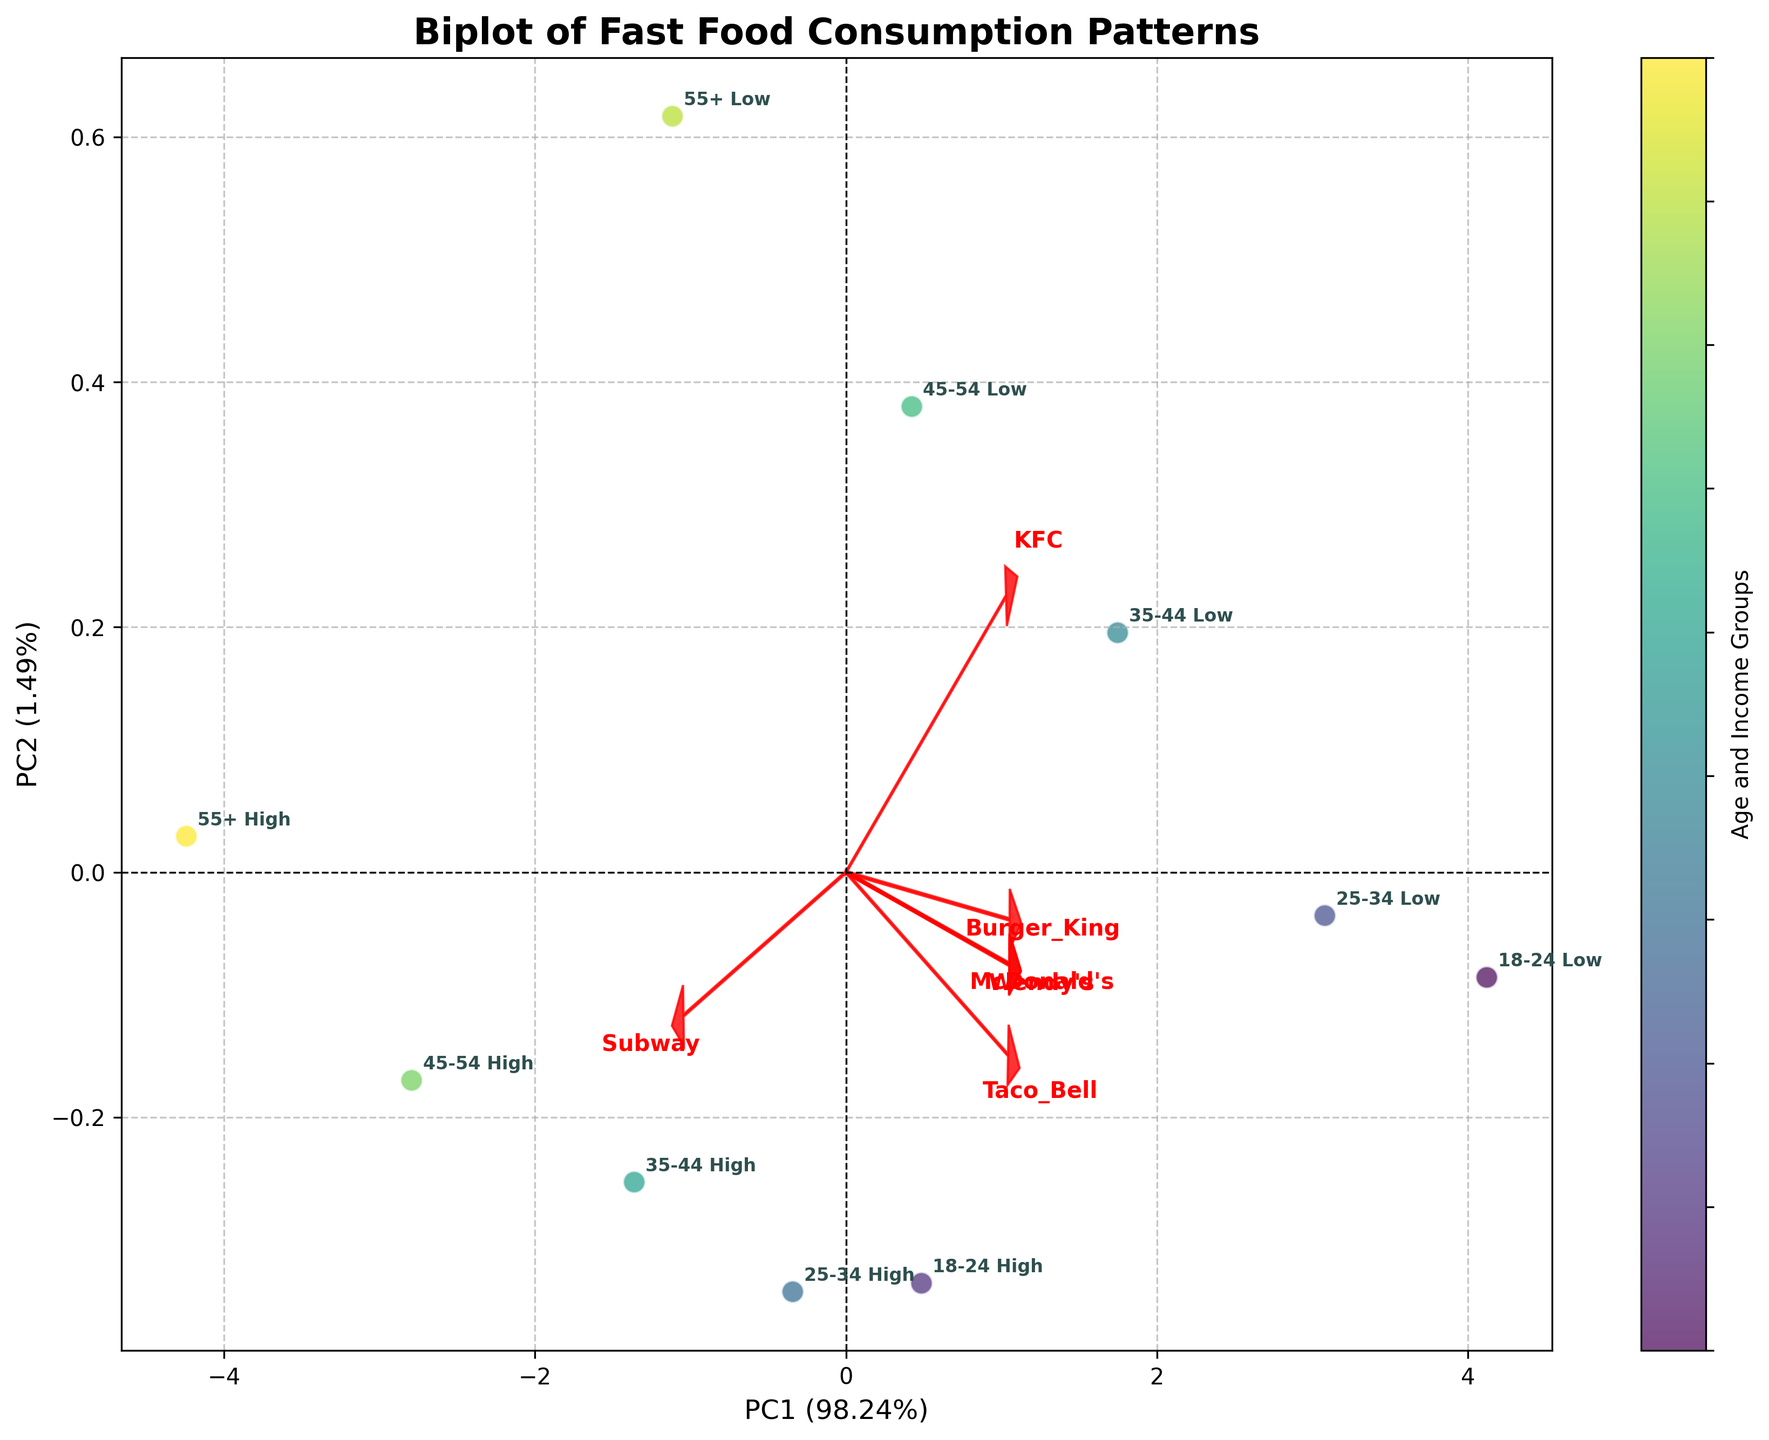What is the title of the plot? The title is typically located at the top of the plot, and it describes the content of the figure.
Answer: Biplot of Fast Food Consumption Patterns Which axis explains the larger percentage of variance? The percentage of variance explained by each axis is labeled on the x and y axes. Here, the x-axis (PC1) has a percentage followed by the y-axis (PC2).
Answer: PC1 What are the labels of the x and y axes? The x and y axes labels are found along the respective axes and indicate what the principal components represent.
Answer: PC1 and PC2 How many distinct groups are labeled on the plot? The annotated text next to each data point represents the combination of age group and income level, which form distinct groups. Count the unique combinations.
Answer: 10 Which fast food chain has a high positive loading on PC1 and PC2? The direction and length of the arrows representing loadings indicate the contribution of each fast food chain. The one with a high positive value on both PC1 and PC2 will be identified by the direction of the red arrows.
Answer: Subway For the age group "18-24 Low", which principal component score is higher, PC1 or PC2? Look at the position of the "18-24 Low" data point along the PC1 (x-axis) and PC2 (y-axis) to determine which has a higher value.
Answer: PC1 Compare the consumption of McDonald's between "18-24 Low" and "55+ High" income groups. Which group consumes more? The plot positions these groups according to their principal component scores, which are influenced by their consumption patterns. Identify their relative positions with respect to the McDonald’s loading vector.
Answer: 18-24 Low Which age and income group is closest to the Taco Bell loading vector? Identify the direction of the Taco Bell loading vector and see which age and income group's data point lies closest to this vector.
Answer: 18-24 Low Which two age and income groups are most similar in their fast food consumption patterns? Look for groups whose data points are closest to each other in the plot, indicating similar principal component scores and thus similar consumption patterns.
Answer: 25-34 Low and 35-44 Low How does the consumption pattern of the "45-54 High" group compare with the "25-34 High" group? Are they similar or different in fast food choices? Compare the positions of these two data points on the biplot. If they are close to each other and follow similar loading vectors, their consumption patterns are similar; otherwise, they differ.
Answer: Different 